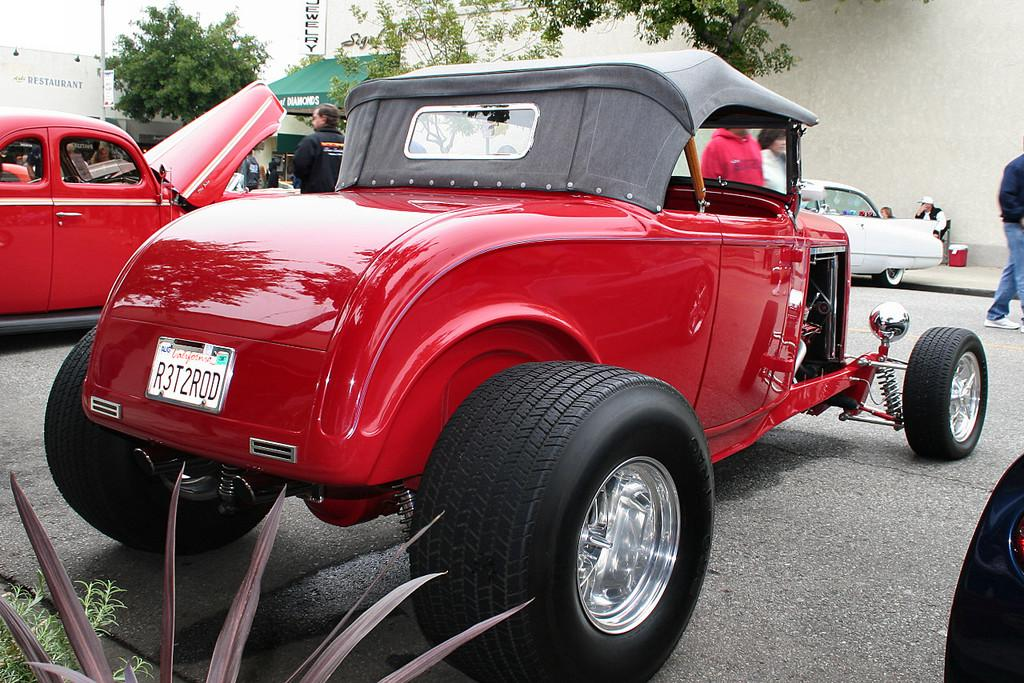What types of objects can be seen in the image? There are vehicles and people in the image. What can be found in the natural environment in the image? There are trees and plants in the image. What is present in the background of the image? There are boards with text in the background of the image. Can you see any legs on the seashore in the image? There is no seashore present in the image, so it is not possible to see any legs on the seashore. 